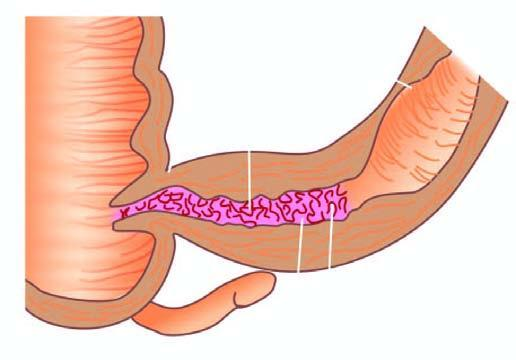what shows segment of thickened wall with narrow lumen which is better appreciated in cross section while intervening areas of the bowel are uninvolved or skipped?
Answer the question using a single word or phrase. Luminal surface of longitudinal cut section 